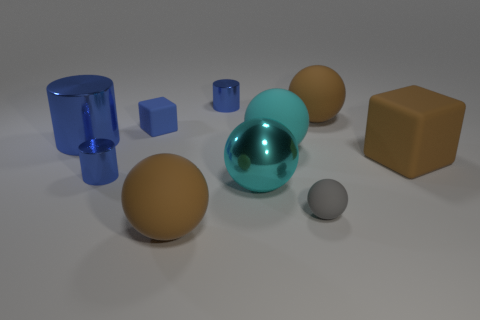What is the shape of the matte thing that is the same color as the large cylinder?
Offer a very short reply. Cube. What is the color of the cylinder that is the same size as the cyan rubber thing?
Your answer should be compact. Blue. Is there a tiny rubber cube of the same color as the shiny sphere?
Your answer should be very brief. No. Does the brown sphere that is in front of the large rubber block have the same size as the blue thing behind the blue block?
Your answer should be very brief. No. What is the large object that is behind the big brown block and left of the cyan shiny ball made of?
Offer a terse response. Metal. There is a matte block that is the same color as the large cylinder; what size is it?
Offer a terse response. Small. What number of other things are the same size as the cyan metallic thing?
Ensure brevity in your answer.  5. There is a big blue cylinder left of the gray ball; what is its material?
Provide a succinct answer. Metal. Do the gray object and the big cyan metallic thing have the same shape?
Ensure brevity in your answer.  Yes. What number of other objects are there of the same shape as the cyan matte thing?
Your response must be concise. 4. 